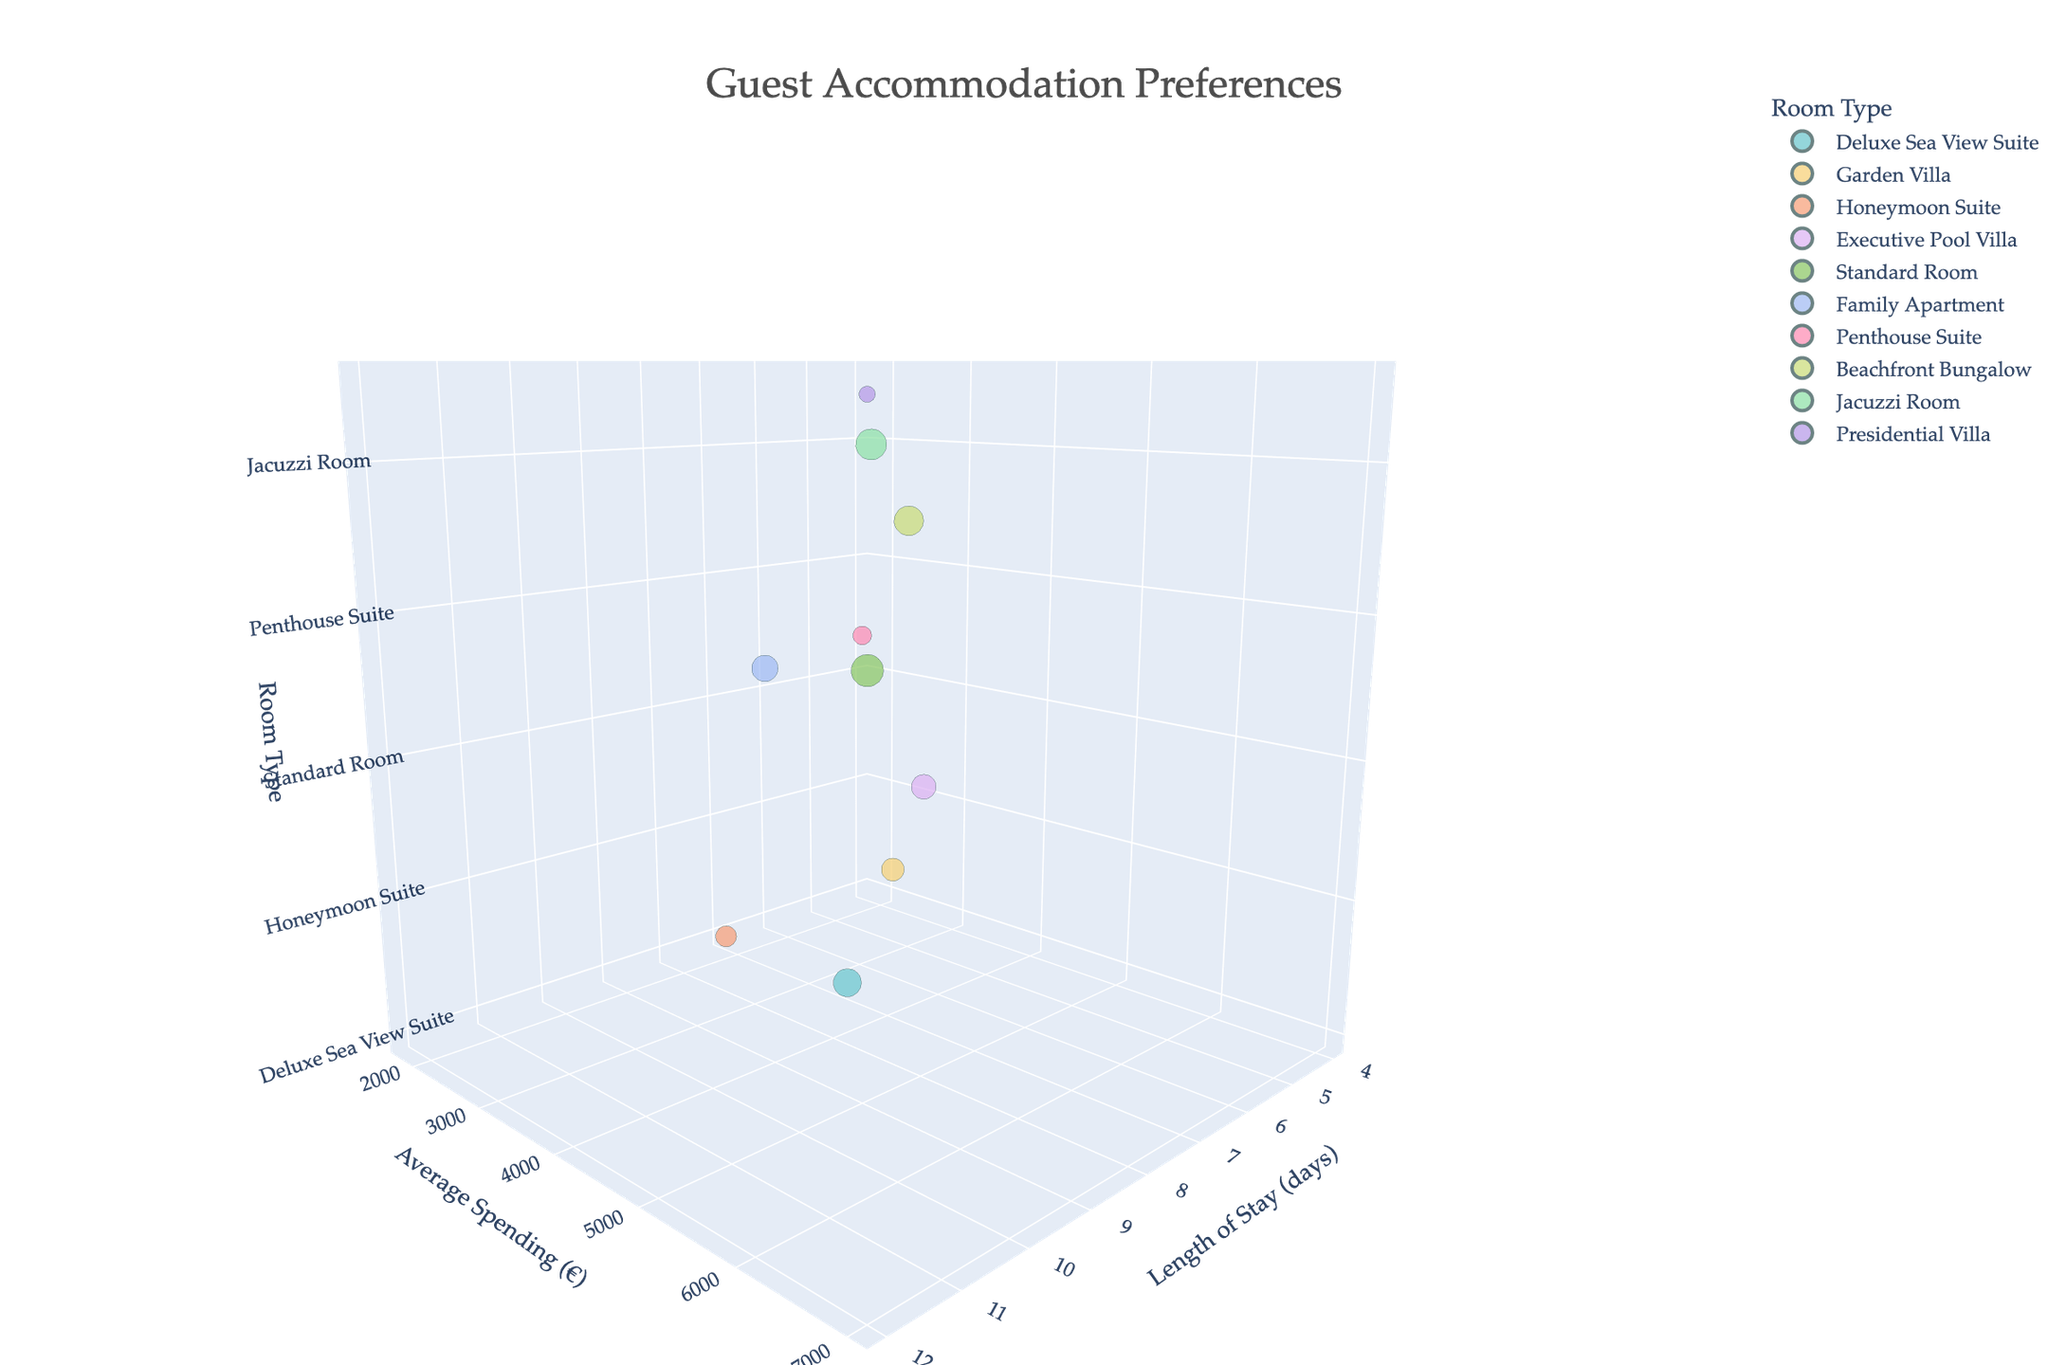How many room types are represented in the chart? Count the number of unique room type labels in the figure.
Answer: 10 Which room type has the highest average spending? Identify the bubble positioned highest on the 'Average Spending (€)' axis.
Answer: Presidential Villa What is the length of stay for guests in the Honeymoon Suite? Locate the Honeymoon Suite bubble and check its position on the 'Length of Stay (days)' axis.
Answer: 10 days Compare the number of guests for the Penthouse Suite and the Standard Room. Which has more guests? Look at the relative sizes of the bubbles for Penthouse Suite and Standard Room and identify the larger one.
Answer: Standard Room What is the relationship between the length of stay and average spending for the Beachfront Bungalow? Find the Beachfront Bungalow bubble and note its positions on the 'Length of Stay (days)' and 'Average Spending (€)' axes.
Answer: 6 days, €3600 Which room type has the shortest length of stay? Identify the bubble closest to the origin on the 'Length of Stay (days)' axis.
Answer: Standard Room Compare the average spending for the Deluxe Sea View Suite and the Garden Villa. Which has higher spending? Compare the positions of the bubbles for Deluxe Sea View Suite and Garden Villa on the 'Average Spending (€)' axis.
Answer: Deluxe Sea View Suite In which room type do guests stay the longest? Find the bubble furthest along the 'Length of Stay (days)' axis.
Answer: Presidential Villa How many guests stay in the Jacuzzi Room? Look at the size of the bubble for the Jacuzzi Room and refer to the legend or labels.
Answer: 55 guests What is the combined average spending for the Executive Pool Villa and the Family Apartment? Sum the average spending values of the bubbles for Executive Pool Villa and Family Apartment (€3800 + €3200).
Answer: €7000 